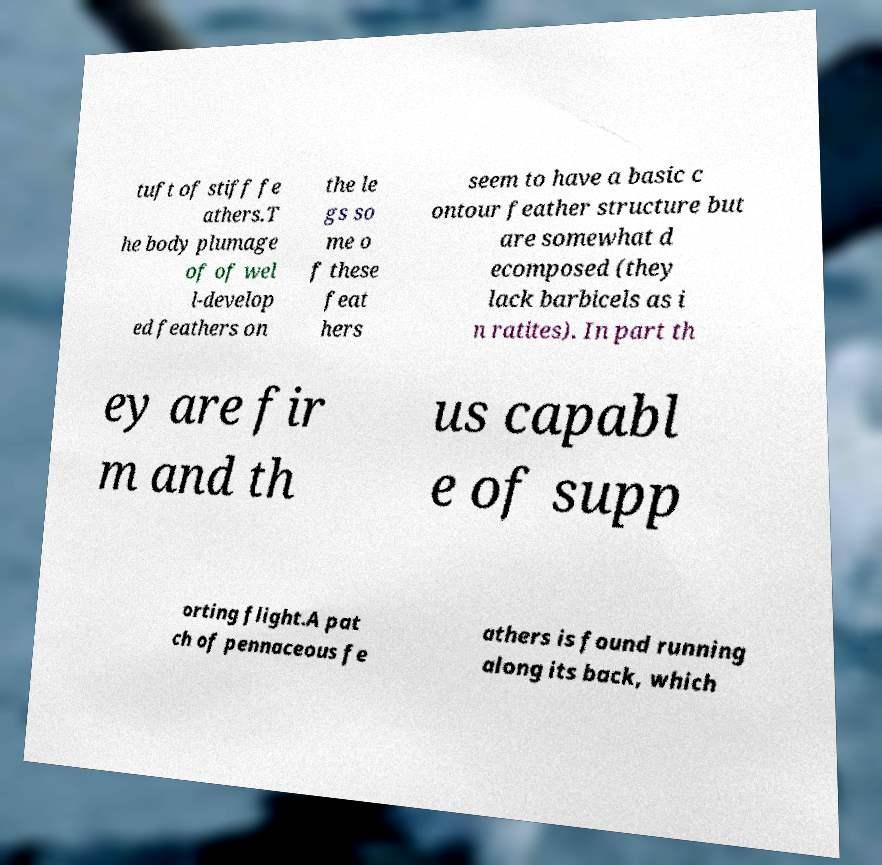What messages or text are displayed in this image? I need them in a readable, typed format. tuft of stiff fe athers.T he body plumage of of wel l-develop ed feathers on the le gs so me o f these feat hers seem to have a basic c ontour feather structure but are somewhat d ecomposed (they lack barbicels as i n ratites). In part th ey are fir m and th us capabl e of supp orting flight.A pat ch of pennaceous fe athers is found running along its back, which 